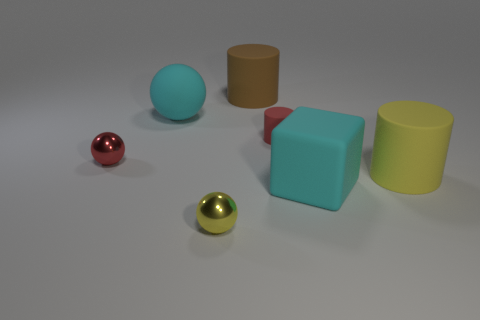Can you tell which object is the largest in the image? The largest object in the image appears to be the light blue cube. 